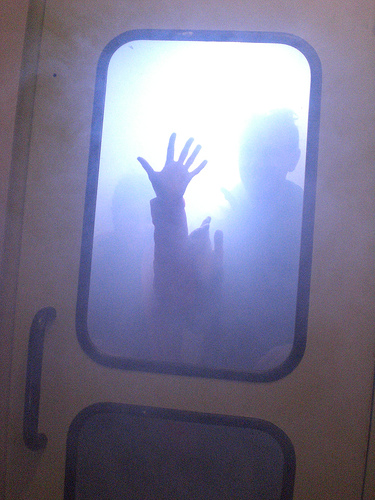<image>
Can you confirm if the person is behind the door? Yes. From this viewpoint, the person is positioned behind the door, with the door partially or fully occluding the person. 